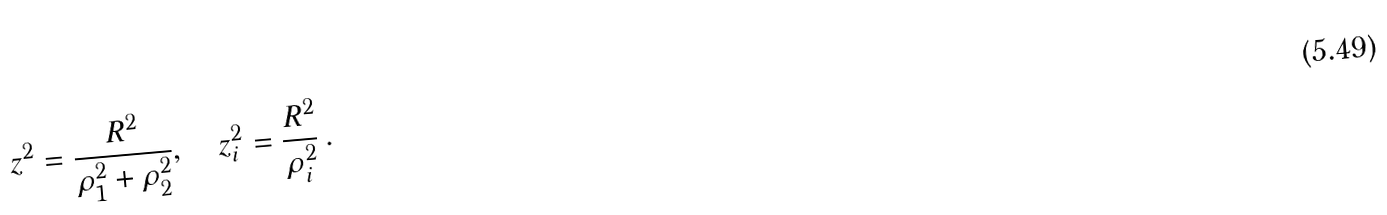<formula> <loc_0><loc_0><loc_500><loc_500>z ^ { 2 } = \frac { R ^ { 2 } } { \rho ^ { 2 } _ { 1 } + \rho ^ { 2 } _ { 2 } } , \quad z ^ { 2 } _ { i } = \frac { R ^ { 2 } } { \rho ^ { 2 } _ { i } } \, .</formula> 